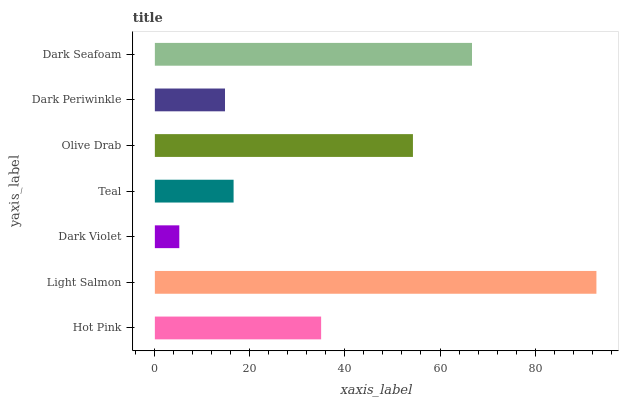Is Dark Violet the minimum?
Answer yes or no. Yes. Is Light Salmon the maximum?
Answer yes or no. Yes. Is Light Salmon the minimum?
Answer yes or no. No. Is Dark Violet the maximum?
Answer yes or no. No. Is Light Salmon greater than Dark Violet?
Answer yes or no. Yes. Is Dark Violet less than Light Salmon?
Answer yes or no. Yes. Is Dark Violet greater than Light Salmon?
Answer yes or no. No. Is Light Salmon less than Dark Violet?
Answer yes or no. No. Is Hot Pink the high median?
Answer yes or no. Yes. Is Hot Pink the low median?
Answer yes or no. Yes. Is Teal the high median?
Answer yes or no. No. Is Olive Drab the low median?
Answer yes or no. No. 